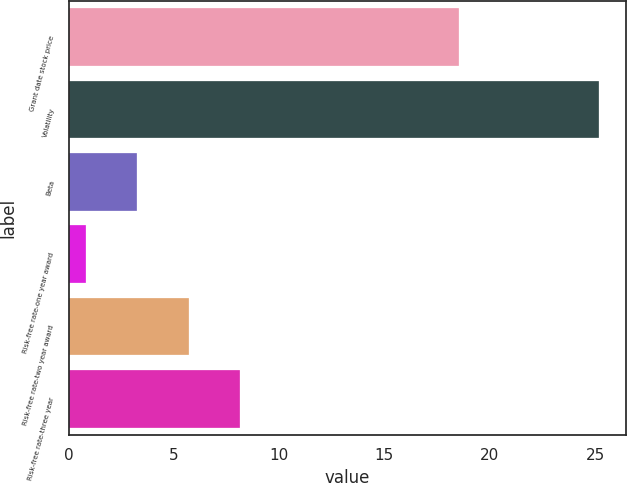Convert chart to OTSL. <chart><loc_0><loc_0><loc_500><loc_500><bar_chart><fcel>Grant date stock price<fcel>Volatility<fcel>Beta<fcel>Risk-free rate-one year award<fcel>Risk-free rate-two year award<fcel>Risk-free rate-three year<nl><fcel>18.56<fcel>25.2<fcel>3.26<fcel>0.82<fcel>5.7<fcel>8.14<nl></chart> 